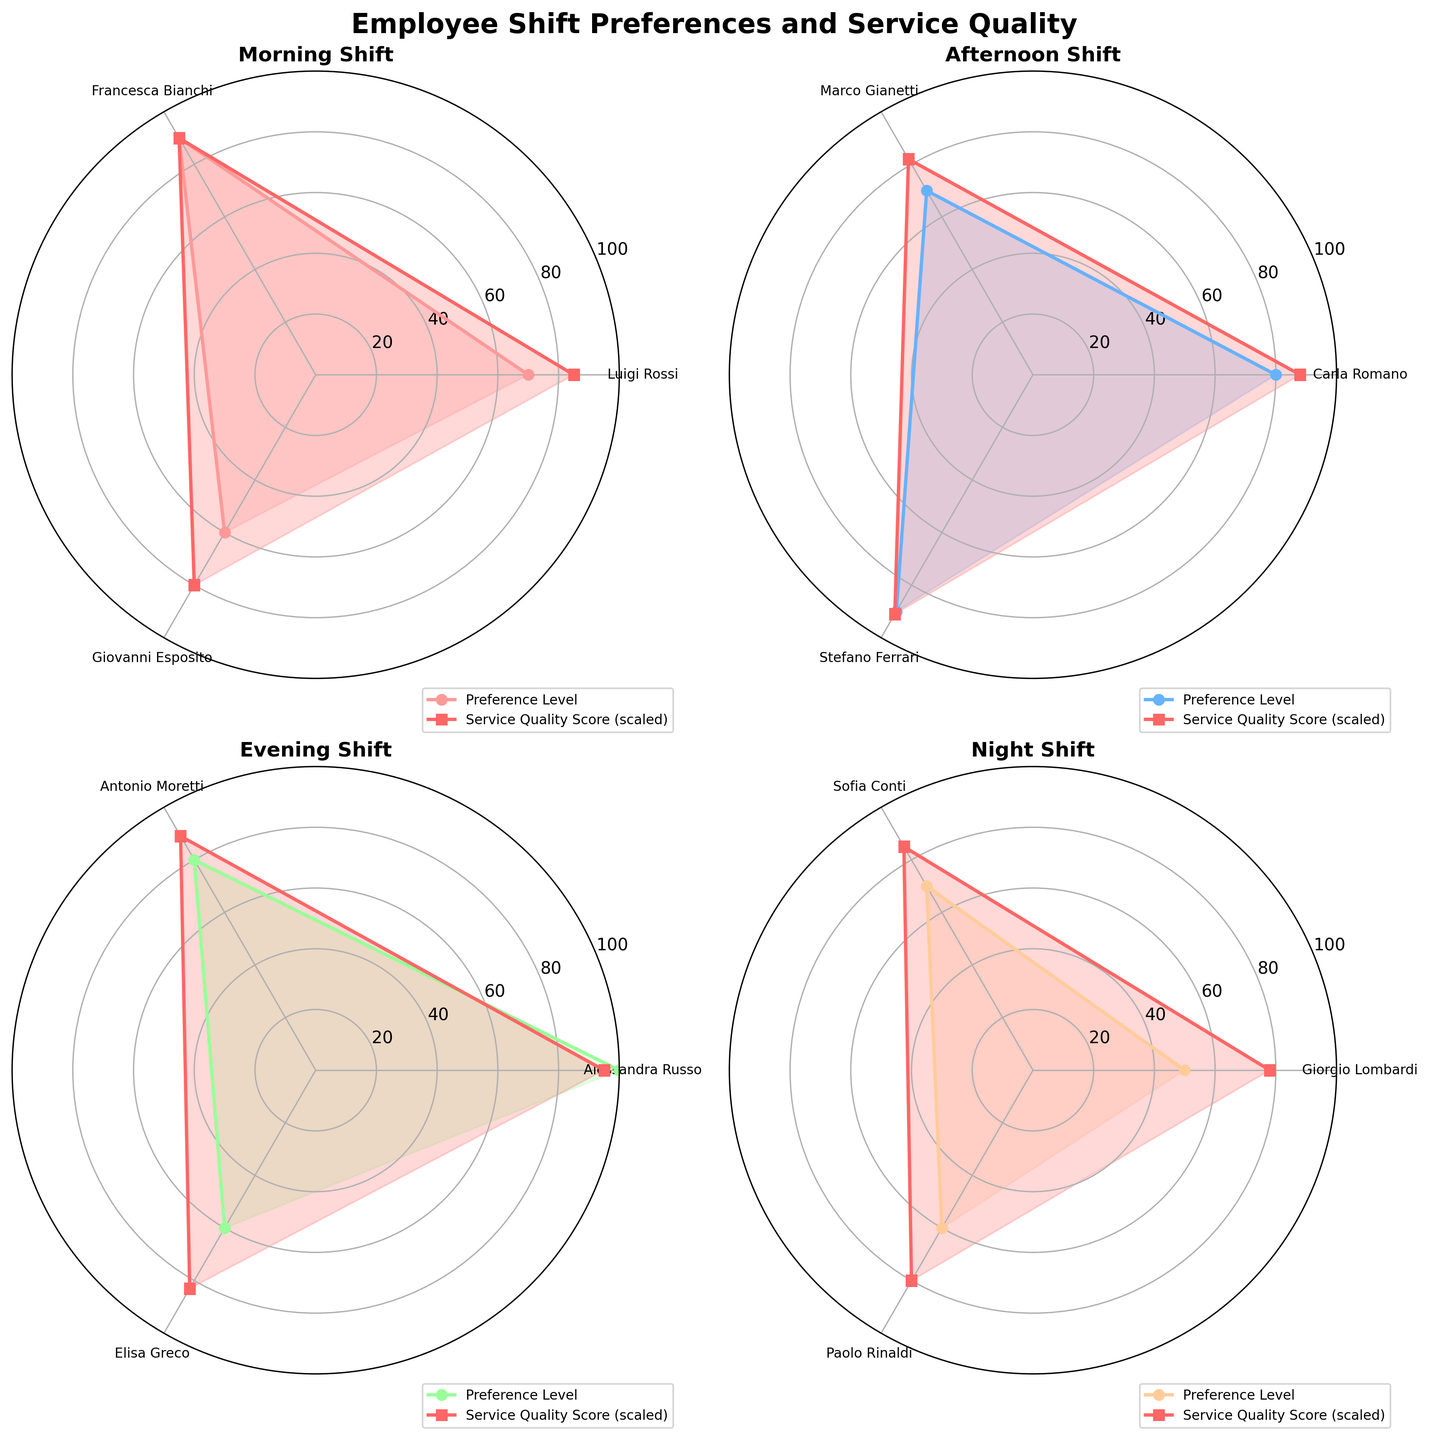What is the title of the figure? The title is usually located at the top center of the figure. By reading this, you can easily identify the main topic or focus of the plot.
Answer: Employee Shift Preferences and Service Quality Which shift has the highest employee preference level? Look at the peaks of the Preference Level lines across all shifts. The highest peak indicates the highest preference level.
Answer: Evening How does Francesca Bianchi's service quality compare to Giovanni Esposito's in the Morning shift? Francesca Bianchi's service quality score can be read from the Morning subplot by finding the corresponding label and value. Compare this to Giovanni Esposito's score in the same subplot.
Answer: Higher What is the average service quality score for the Night shift? Add up the service quality scores for Giorgio Lombardi, Sofia Conti, and Paolo Rinaldi, then divide by the number of employees (3).
Answer: \( (78 + 85 + 80) / 3 = 81 \) Which employee has the lowest preference level in the Evening shift? Identify the employee with the lowest Preference Level score by looking at the Evening subplot.
Answer: Elisa Greco In which shift do we observe the largest range in employee preference levels? Compute the range (maximum - minimum) in Preference Level for each shift and identify the one with the largest difference.
Answer: Evening (range of 4) Is there a shift where service quality scores are equally distributed among employees? Check if any shift subplot shows equal values or very close values among all employees' service quality scores.
Answer: No What is the difference between the highest and lowest service quality scores in the Afternoon shift? Subtract the lowest service quality score from the highest in the Afternoon subplot.
Answer: \( 91 - 82 = 9 \) Do any shifts show a directly proportional relationship between preference level and service quality score? Analyze if higher Preference Levels consistently correspond to higher Service Quality Scores within any shift.
Answer: Yes, Evening Which shift shows the most uniform preference levels among its employees? Check the subplots for the shift where the Preference Level values are closest together, indicating uniformity.
Answer: Afternoon 